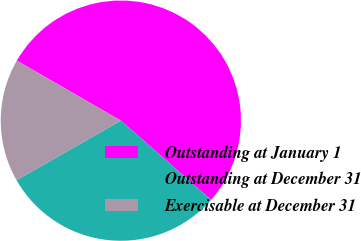<chart> <loc_0><loc_0><loc_500><loc_500><pie_chart><fcel>Outstanding at January 1<fcel>Outstanding at December 31<fcel>Exercisable at December 31<nl><fcel>53.14%<fcel>30.28%<fcel>16.58%<nl></chart> 